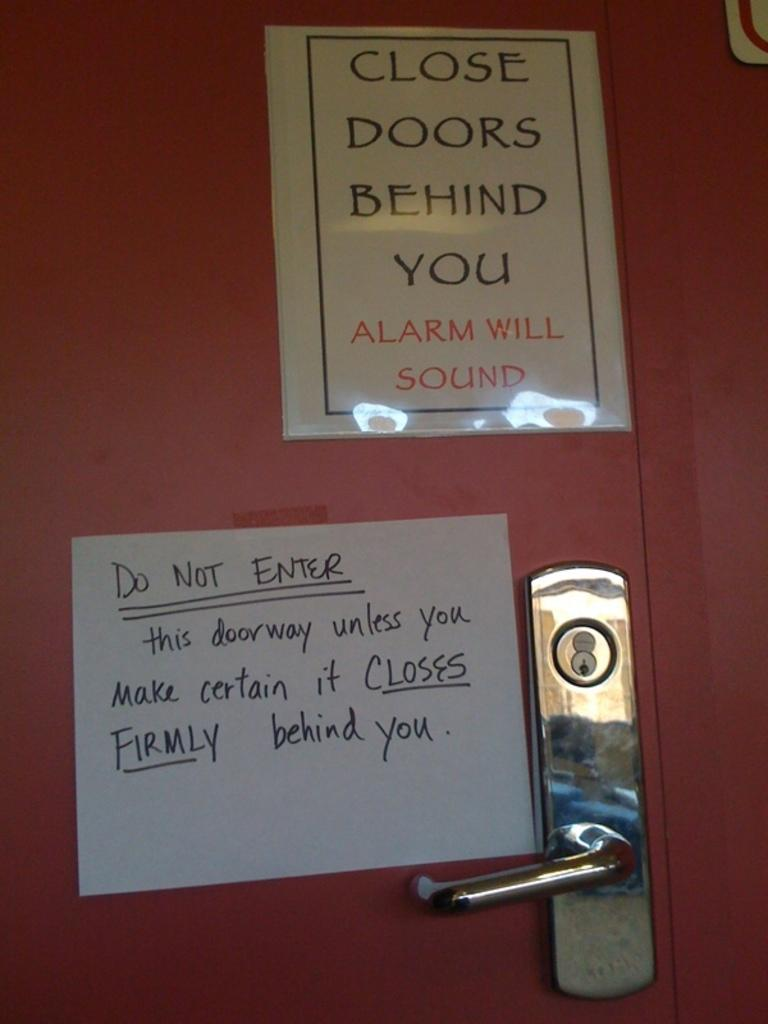Provide a one-sentence caption for the provided image. A couple of signs stating the importance of the door being closed. 